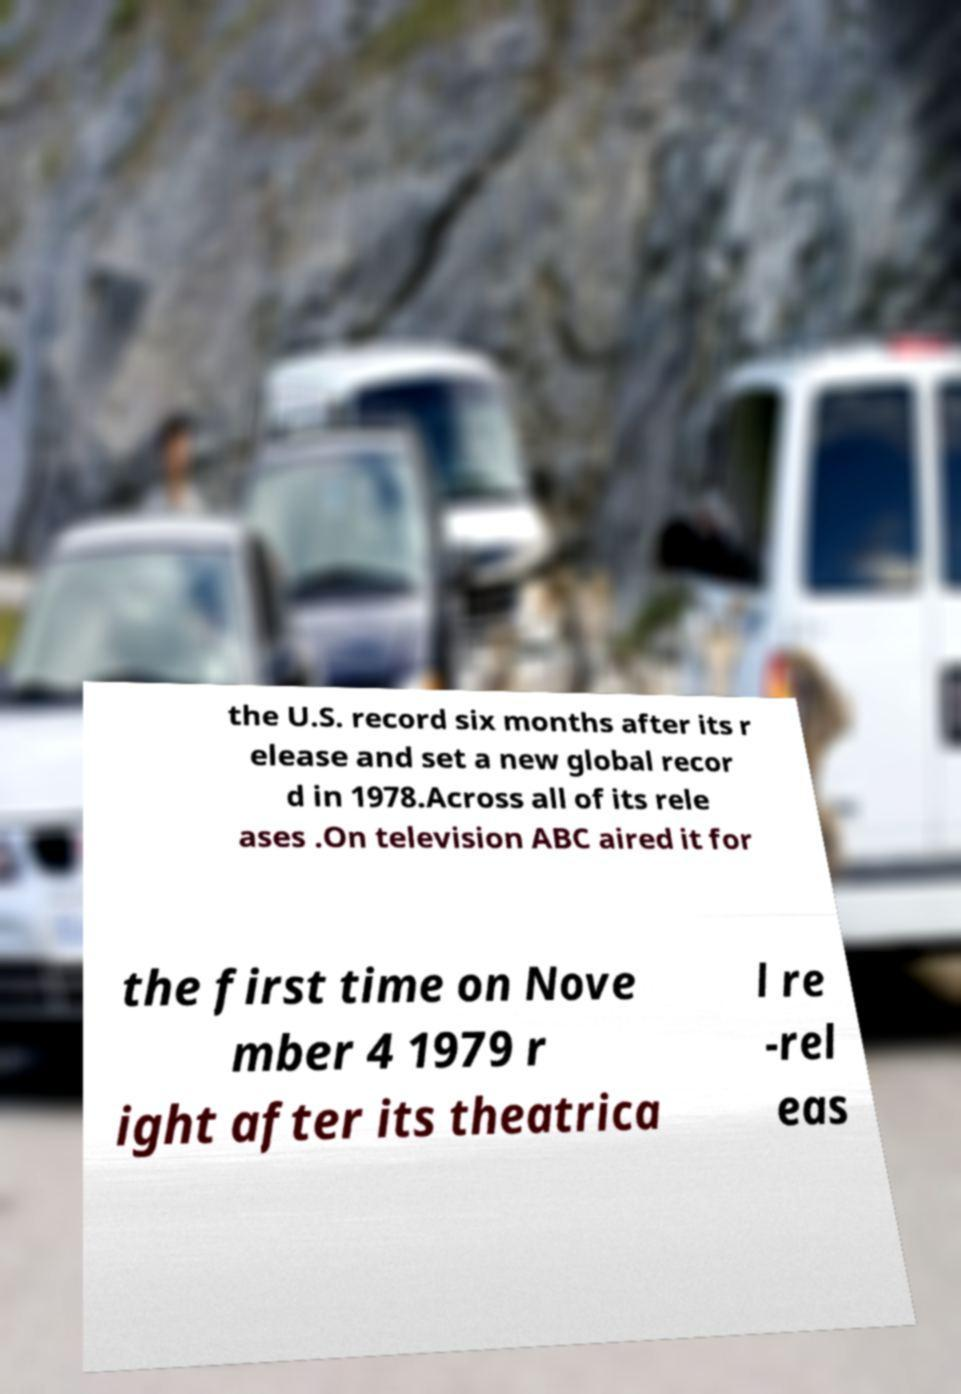Can you accurately transcribe the text from the provided image for me? the U.S. record six months after its r elease and set a new global recor d in 1978.Across all of its rele ases .On television ABC aired it for the first time on Nove mber 4 1979 r ight after its theatrica l re -rel eas 